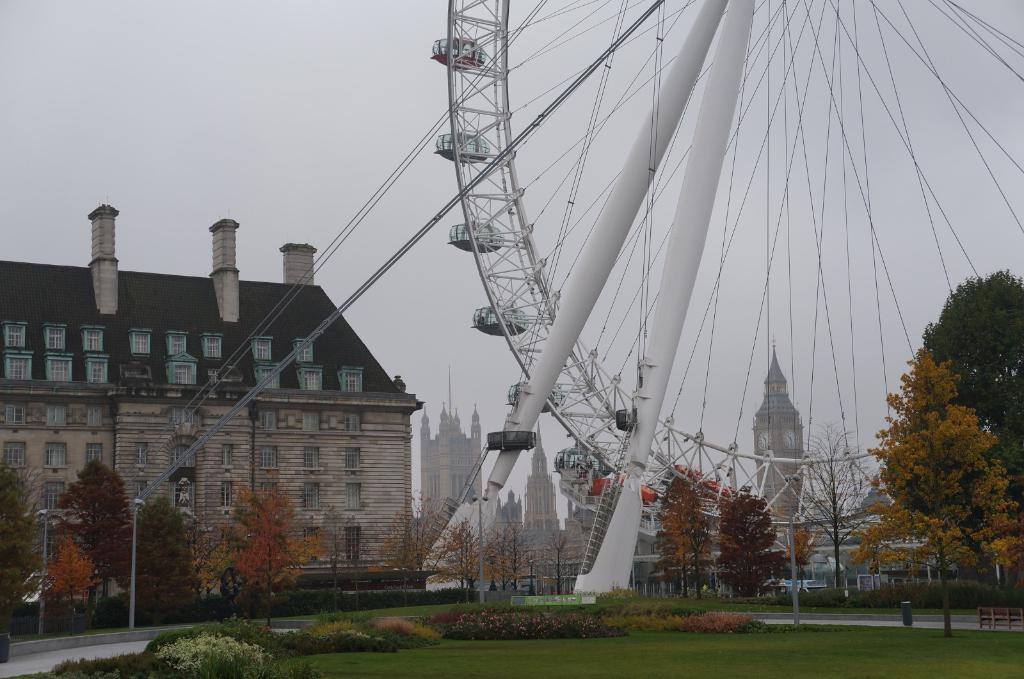Could you give a brief overview of what you see in this image? This is grass. Here we can see plants, trees, poles, buildings, and a joint wheel. In the background there is sky. 